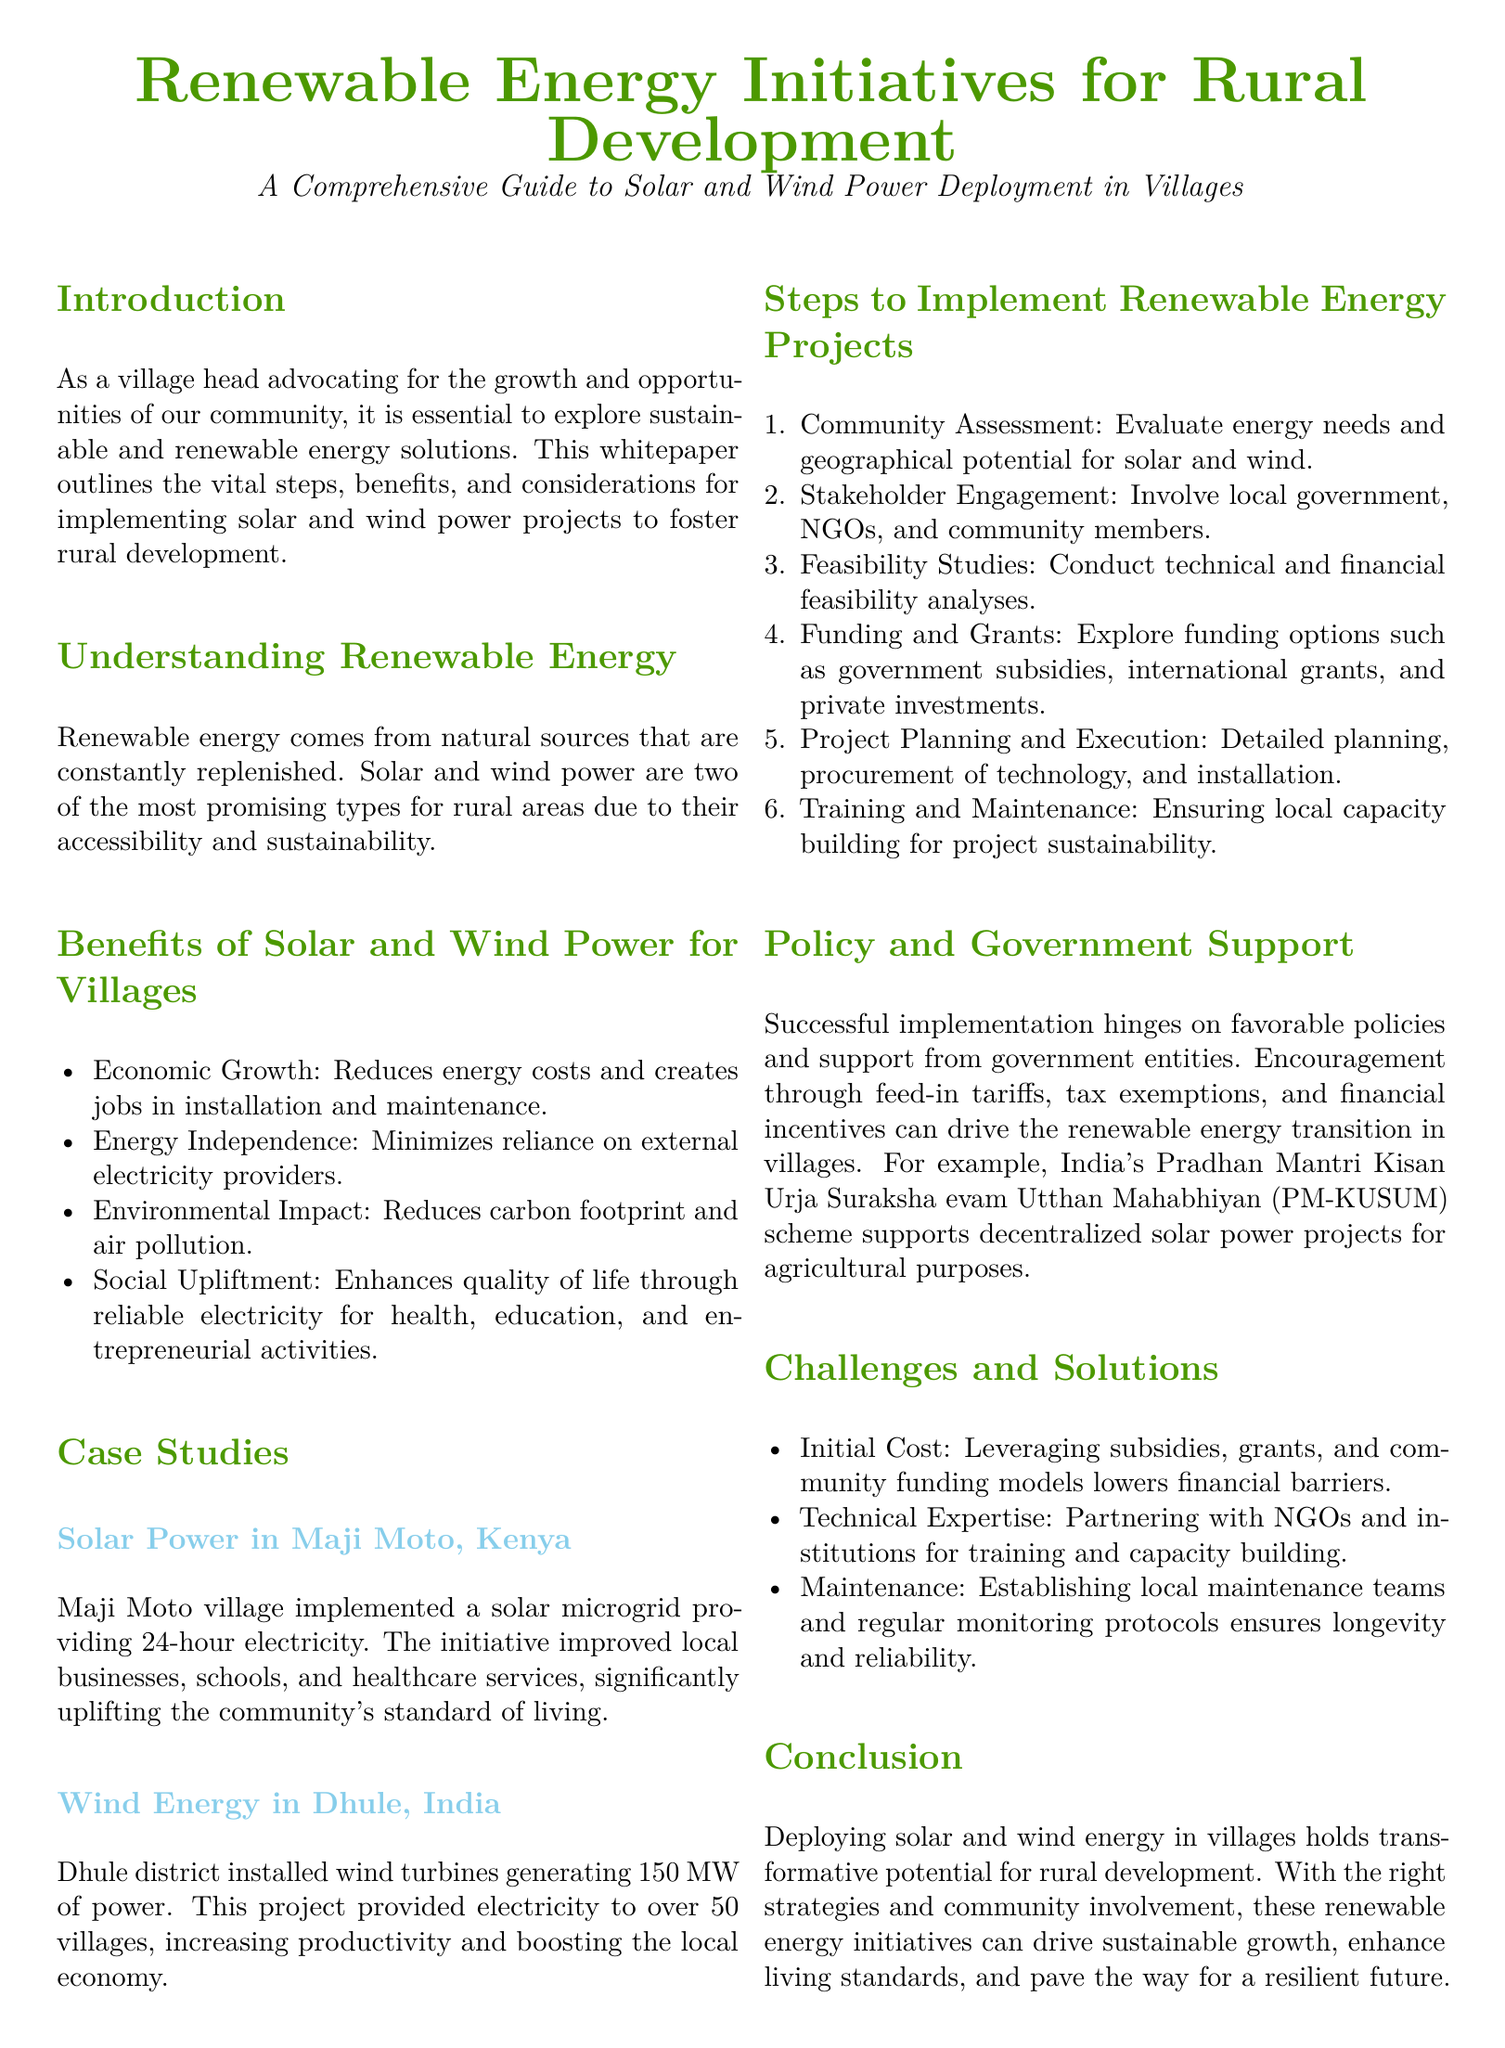What are the two main types of renewable energy highlighted for rural areas? The document states that solar and wind power are the two promising types for rural areas.
Answer: solar and wind power What is the economic benefit mentioned for villages adopting renewable energy? The document mentions that it reduces energy costs and creates jobs in installation and maintenance.
Answer: Economic Growth In which country did the solar microgrid project take place? The document specifies that the solar microgrid project was implemented in Maji Moto, Kenya.
Answer: Kenya How many villages benefited from the wind energy project in Dhule? The document indicates that over 50 villages received electricity from the project.
Answer: over 50 villages What is one of the initial steps to implement renewable energy projects according to the document? The document lists 'Community Assessment' as one of the initial steps in project implementation.
Answer: Community Assessment What governmental scheme supports decentralized solar power projects for agriculture in India? The document refers to India's PM-KUSUM scheme as the supportive governmental initiative.
Answer: PM-KUSUM What challenge related to renewable energy projects is addressed in the document? One of the challenges outlined is the initial cost of implementation.
Answer: Initial Cost What is one solution proposed for ensuring technical expertise in renewable energy projects? Partnering with NGOs and institutions for training is suggested as a solution for technical expertise.
Answer: Partnering with NGOs What is the primary goal of deploying solar and wind energy in villages? The document states the goal is to foster rural development and sustainable growth.
Answer: rural development 